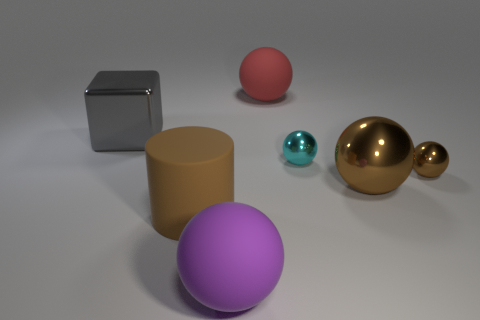Subtract all metallic balls. How many balls are left? 2 Add 2 big red blocks. How many objects exist? 9 Subtract all purple cubes. How many brown spheres are left? 2 Subtract all brown balls. How many balls are left? 3 Subtract all cubes. How many objects are left? 6 Subtract all gray balls. Subtract all yellow cylinders. How many balls are left? 5 Subtract all small cyan metal balls. Subtract all brown rubber objects. How many objects are left? 5 Add 3 matte cylinders. How many matte cylinders are left? 4 Add 1 tiny gray shiny cubes. How many tiny gray shiny cubes exist? 1 Subtract 1 brown balls. How many objects are left? 6 